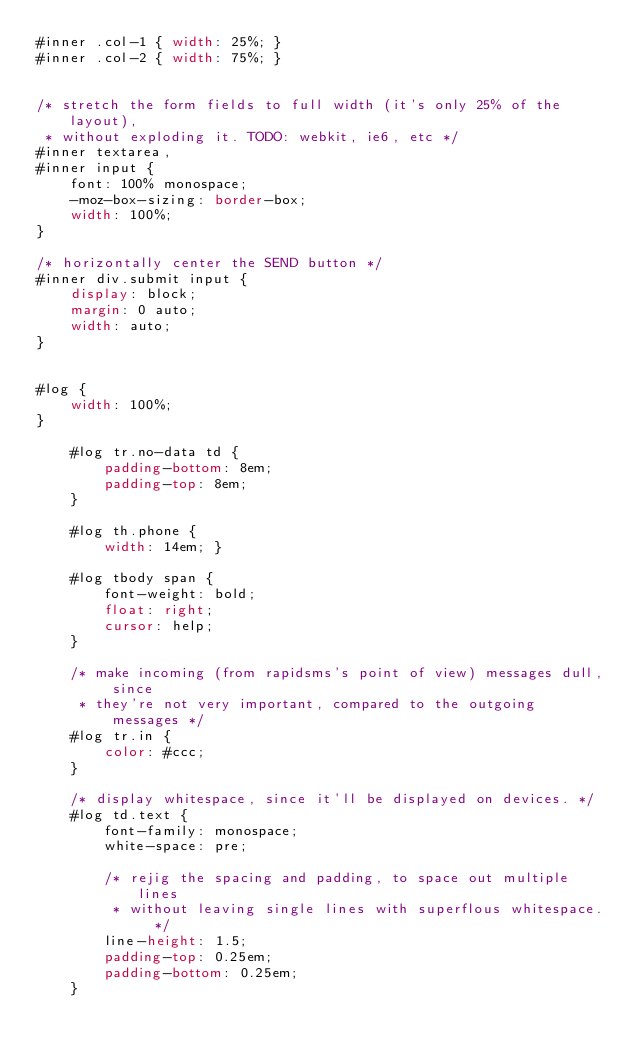<code> <loc_0><loc_0><loc_500><loc_500><_CSS_>#inner .col-1 { width: 25%; }
#inner .col-2 { width: 75%; }


/* stretch the form fields to full width (it's only 25% of the layout),
 * without exploding it. TODO: webkit, ie6, etc */
#inner textarea,
#inner input {
	font: 100% monospace;
	-moz-box-sizing: border-box;
	width: 100%;
}

/* horizontally center the SEND button */
#inner div.submit input {
	display: block;
	margin: 0 auto;
	width: auto;
}


#log {
	width: 100%;
}

	#log tr.no-data td {
		padding-bottom: 8em;
		padding-top: 8em;
	}

	#log th.phone {
		width: 14em; }

	#log tbody span {
		font-weight: bold;
		float: right;
		cursor: help;
	}

	/* make incoming (from rapidsms's point of view) messages dull, since
	 * they're not very important, compared to the outgoing messages */
	#log tr.in {
		color: #ccc;
	}

	/* display whitespace, since it'll be displayed on devices. */
	#log td.text {
		font-family: monospace;
		white-space: pre;

		/* rejig the spacing and padding, to space out multiple lines
		 * without leaving single lines with superflous whitespace. */
		line-height: 1.5;
		padding-top: 0.25em;
		padding-bottom: 0.25em;
	}
</code> 